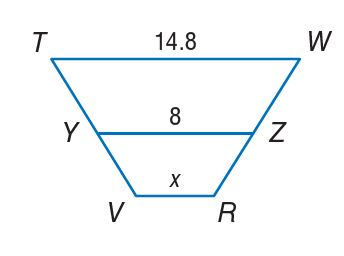Answer the mathemtical geometry problem and directly provide the correct option letter.
Question: In the figure at the right, Y Z is the midsegment of trapezoid T W R V. Determine the value of x.
Choices: A: 1.2 B: 8 C: 14.8 D: 16 A 